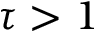<formula> <loc_0><loc_0><loc_500><loc_500>\tau > 1</formula> 